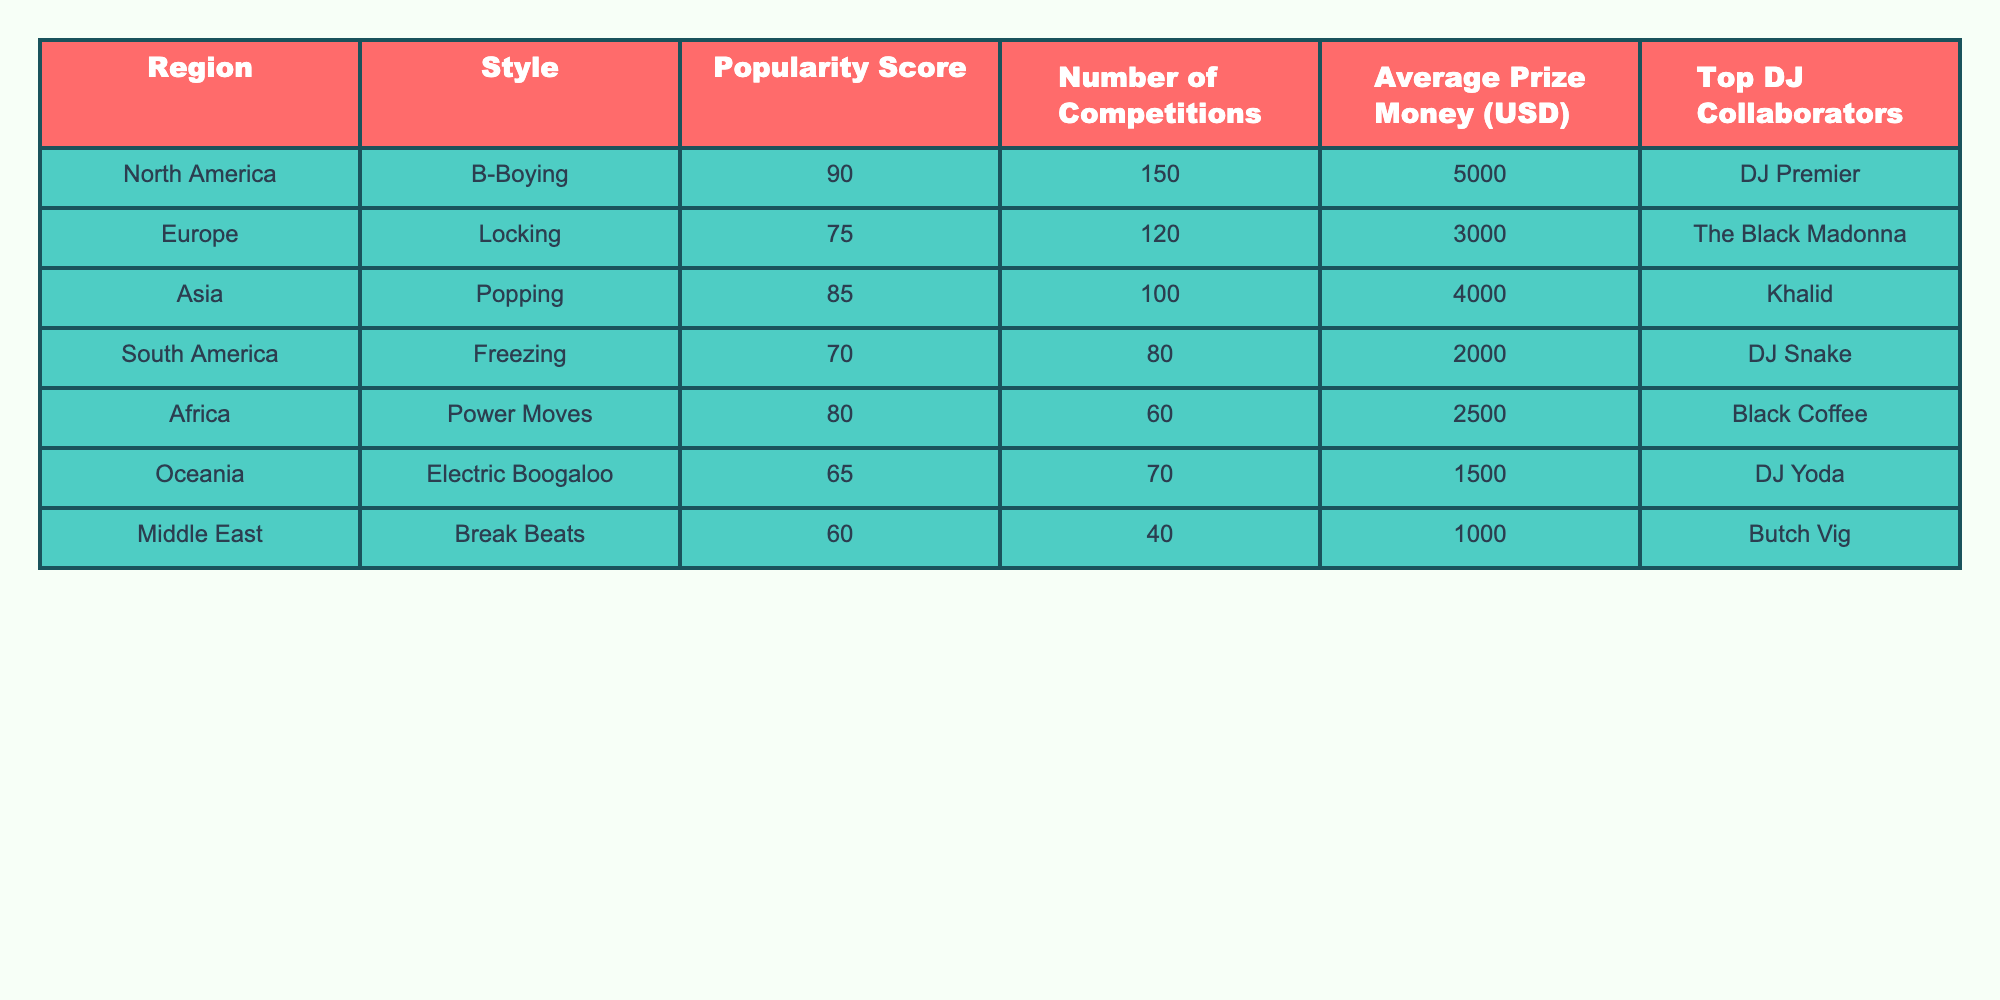What is the highest popularity score among the styles listed? The highest popularity score can be found in the "Popularity Score" column. Scanning the values shows that B-Boying has the highest score of 90.
Answer: 90 Which region has the lowest average prize money? To find the lowest average prize money, we look at the "Average Prize Money (USD)" column. The minimum value is $1000, which corresponds to the Middle East region.
Answer: $1000 How many total competitions are held in North America and Europe combined? We add the number of competitions in North America (150) and Europe (120). The total is 150 + 120 = 270.
Answer: 270 What is the average popularity score of the break dancing styles in Africa and South America? We first identify the popularity scores for Africa (80) and South America (70). Adding them gives 80 + 70 = 150. To find the average, we divide by 2: 150 / 2 = 75.
Answer: 75 Is Locking the style with the highest number of competitions? We check the "Number of Competitions" for Locking (120) against other styles. B-Boying has 150 competitions, which is higher. Thus, Locking is not the highest.
Answer: No Which style has the highest average prize money and what is the amount? Looking at the "Average Prize Money (USD)" column, we find B-Boying has the highest average prize money of $5000.
Answer: $5000 What is the difference in popularity scores between B-Boying and Freezing? We subtract the popularity score of Freezing (70) from that of B-Boying (90): 90 - 70 = 20.
Answer: 20 If you combine the prize money from Locking and Popping, what total do you get? The average prize money for Locking is $3000 and for Popping is $4000. Adding these amounts gives $3000 + $4000 = $7000.
Answer: $7000 Which region has the most DJ collaborators listed and who are they? We check the "Top DJ Collaborators" column for unique names per region. Every region has one collaborator; thus, no region stands out with more than one listed.
Answer: N/A Is the relationship between popularity scores and average prize money positive across all regions? To analyze, we assess if higher popularity scores generally correspond to higher average prize money values. Comparing scores and prize money, a positive relationship is not evident in all cases, particularly with lower scores having higher prize money sometimes.
Answer: No 